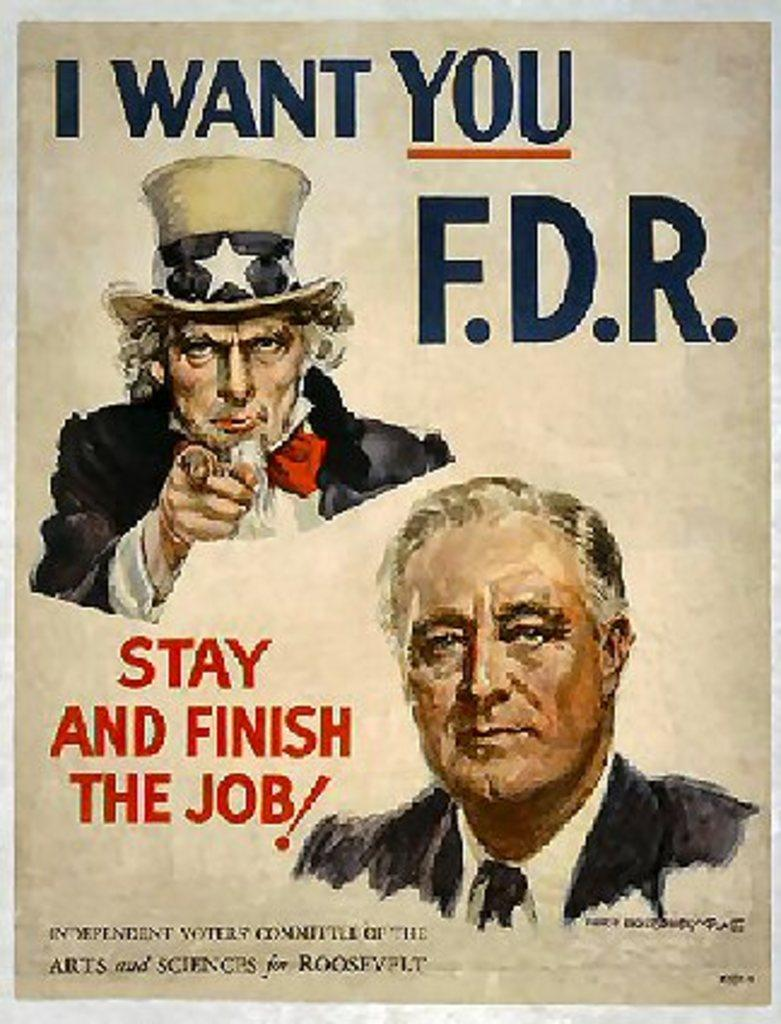What is present on the poster in the image? There is a poster in the image, and it contains two pictures. What text is printed on the poster? The text "I WANT YOUR F. D. R" is printed on the poster. How many dinosaurs are depicted on the poster? There are no dinosaurs depicted on the poster; it contains two pictures, but they are not of dinosaurs. What type of glove is shown in the image? There is no glove present in the image; it only features the poster with the text "I WANT YOUR F. D. R" and two pictures. 